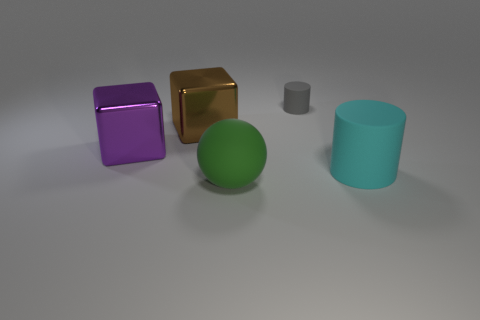There is a large thing that is both in front of the purple metallic cube and to the left of the large cyan thing; what material is it made of?
Provide a succinct answer. Rubber. Is there a cyan thing that has the same size as the cyan rubber cylinder?
Make the answer very short. No. There is a brown block that is the same size as the ball; what is its material?
Keep it short and to the point. Metal. There is a large matte ball; what number of balls are in front of it?
Offer a terse response. 0. Does the object that is behind the brown metal object have the same shape as the large purple thing?
Give a very brief answer. No. Is there another tiny thing that has the same shape as the gray matte thing?
Make the answer very short. No. There is a matte thing behind the matte cylinder that is in front of the tiny gray rubber cylinder; what is its shape?
Give a very brief answer. Cylinder. What number of large purple balls have the same material as the cyan object?
Provide a short and direct response. 0. The block that is made of the same material as the big brown thing is what color?
Offer a terse response. Purple. There is a rubber thing that is to the right of the cylinder that is behind the large matte thing that is right of the big green thing; what is its size?
Offer a terse response. Large. 